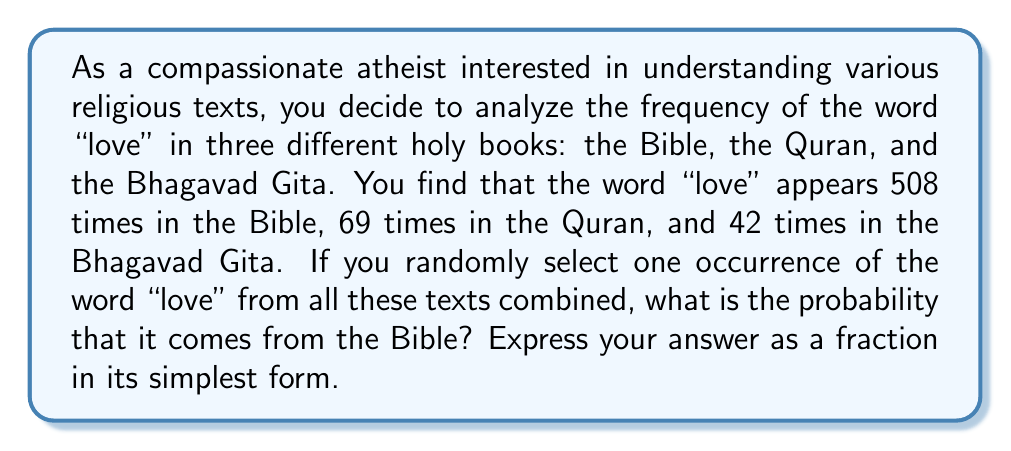What is the answer to this math problem? To solve this problem, we need to follow these steps:

1. Calculate the total number of times "love" appears in all three texts combined:
   $$ \text{Total occurrences} = 508 + 69 + 42 = 619 $$

2. The probability of selecting a word from the Bible is the number of occurrences in the Bible divided by the total number of occurrences:
   $$ P(\text{Bible}) = \frac{\text{Occurrences in Bible}}{\text{Total occurrences}} = \frac{508}{619} $$

3. This fraction is already in its simplest form, as 508 and 619 have no common factors other than 1.

Therefore, the probability of randomly selecting an occurrence of "love" from the Bible, given all three texts, is $\frac{508}{619}$.
Answer: $\frac{508}{619}$ 